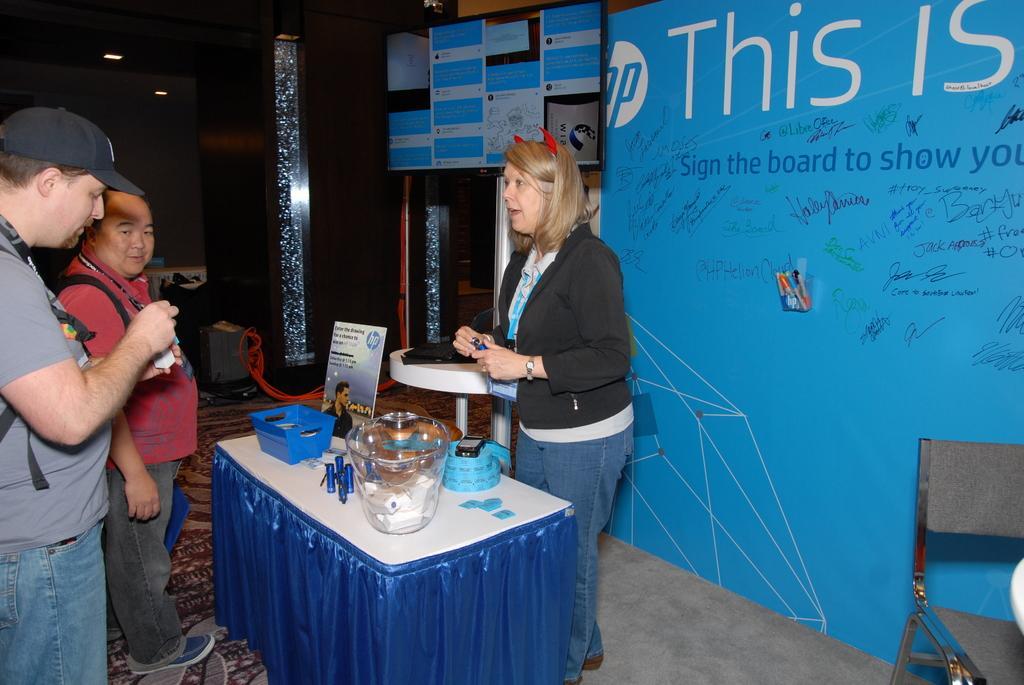In one or two sentences, can you explain what this image depicts? In this picture we can see a woman and two men, in front of them we can see a basket, jar and other things on the table, in the background we can see hoardings and lights, in the bottom right hand corner we can see a chair. 